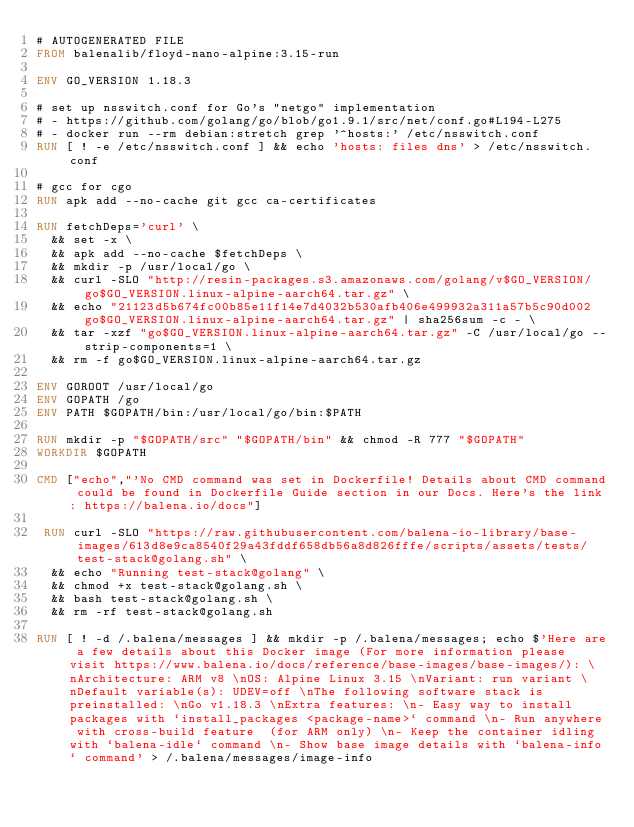Convert code to text. <code><loc_0><loc_0><loc_500><loc_500><_Dockerfile_># AUTOGENERATED FILE
FROM balenalib/floyd-nano-alpine:3.15-run

ENV GO_VERSION 1.18.3

# set up nsswitch.conf for Go's "netgo" implementation
# - https://github.com/golang/go/blob/go1.9.1/src/net/conf.go#L194-L275
# - docker run --rm debian:stretch grep '^hosts:' /etc/nsswitch.conf
RUN [ ! -e /etc/nsswitch.conf ] && echo 'hosts: files dns' > /etc/nsswitch.conf

# gcc for cgo
RUN apk add --no-cache git gcc ca-certificates

RUN fetchDeps='curl' \
	&& set -x \
	&& apk add --no-cache $fetchDeps \
	&& mkdir -p /usr/local/go \
	&& curl -SLO "http://resin-packages.s3.amazonaws.com/golang/v$GO_VERSION/go$GO_VERSION.linux-alpine-aarch64.tar.gz" \
	&& echo "21123d5b674fc00b85e11f14e7d4032b530afb406e499932a311a57b5c90d002  go$GO_VERSION.linux-alpine-aarch64.tar.gz" | sha256sum -c - \
	&& tar -xzf "go$GO_VERSION.linux-alpine-aarch64.tar.gz" -C /usr/local/go --strip-components=1 \
	&& rm -f go$GO_VERSION.linux-alpine-aarch64.tar.gz

ENV GOROOT /usr/local/go
ENV GOPATH /go
ENV PATH $GOPATH/bin:/usr/local/go/bin:$PATH

RUN mkdir -p "$GOPATH/src" "$GOPATH/bin" && chmod -R 777 "$GOPATH"
WORKDIR $GOPATH

CMD ["echo","'No CMD command was set in Dockerfile! Details about CMD command could be found in Dockerfile Guide section in our Docs. Here's the link: https://balena.io/docs"]

 RUN curl -SLO "https://raw.githubusercontent.com/balena-io-library/base-images/613d8e9ca8540f29a43fddf658db56a8d826fffe/scripts/assets/tests/test-stack@golang.sh" \
  && echo "Running test-stack@golang" \
  && chmod +x test-stack@golang.sh \
  && bash test-stack@golang.sh \
  && rm -rf test-stack@golang.sh 

RUN [ ! -d /.balena/messages ] && mkdir -p /.balena/messages; echo $'Here are a few details about this Docker image (For more information please visit https://www.balena.io/docs/reference/base-images/base-images/): \nArchitecture: ARM v8 \nOS: Alpine Linux 3.15 \nVariant: run variant \nDefault variable(s): UDEV=off \nThe following software stack is preinstalled: \nGo v1.18.3 \nExtra features: \n- Easy way to install packages with `install_packages <package-name>` command \n- Run anywhere with cross-build feature  (for ARM only) \n- Keep the container idling with `balena-idle` command \n- Show base image details with `balena-info` command' > /.balena/messages/image-info</code> 